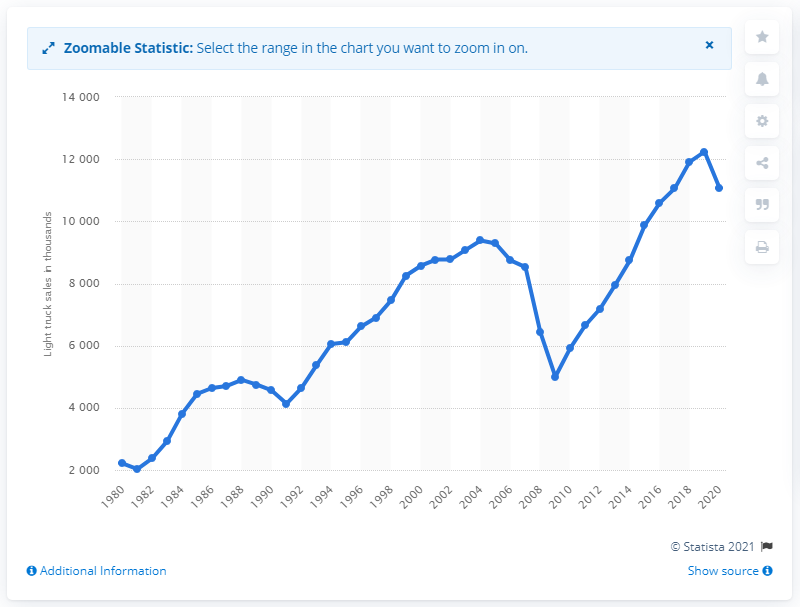Indicate a few pertinent items in this graphic. The auto industry began to recover from low vehicle purchases after the 2008-2009 financial crisis in 2010. 